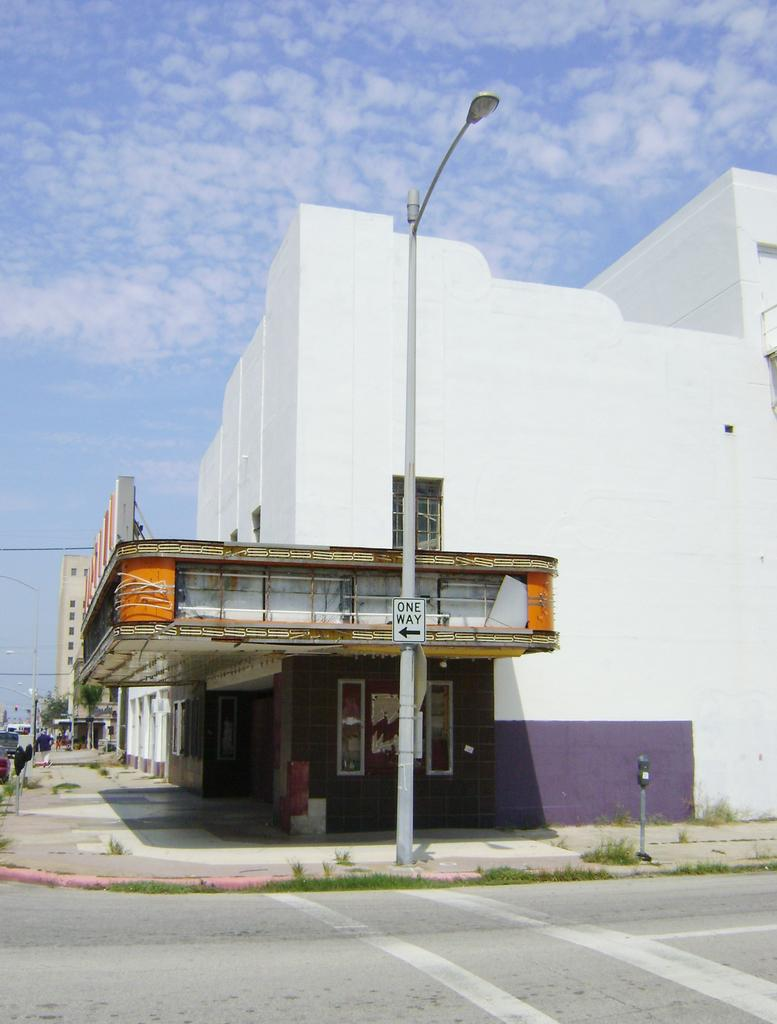What type of structures can be seen in the image? There are buildings in the image. What is located near the buildings? There is a sign board and poles in the image. What can be found on the pathway in the image? There are plants on the pathway in the image. What is visible in the background of the image? There are trees and clouds in the background of the image. Can you see any horses running through the waves in the image? There are no horses or waves present in the image. 